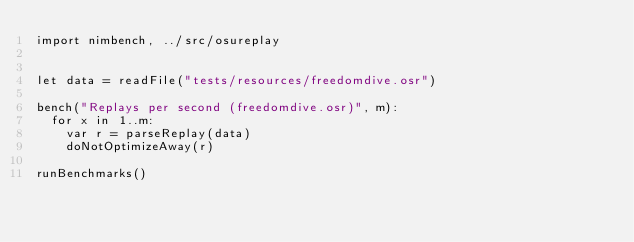<code> <loc_0><loc_0><loc_500><loc_500><_Nim_>import nimbench, ../src/osureplay


let data = readFile("tests/resources/freedomdive.osr")

bench("Replays per second (freedomdive.osr)", m):
  for x in 1..m:
    var r = parseReplay(data)
    doNotOptimizeAway(r)

runBenchmarks()</code> 